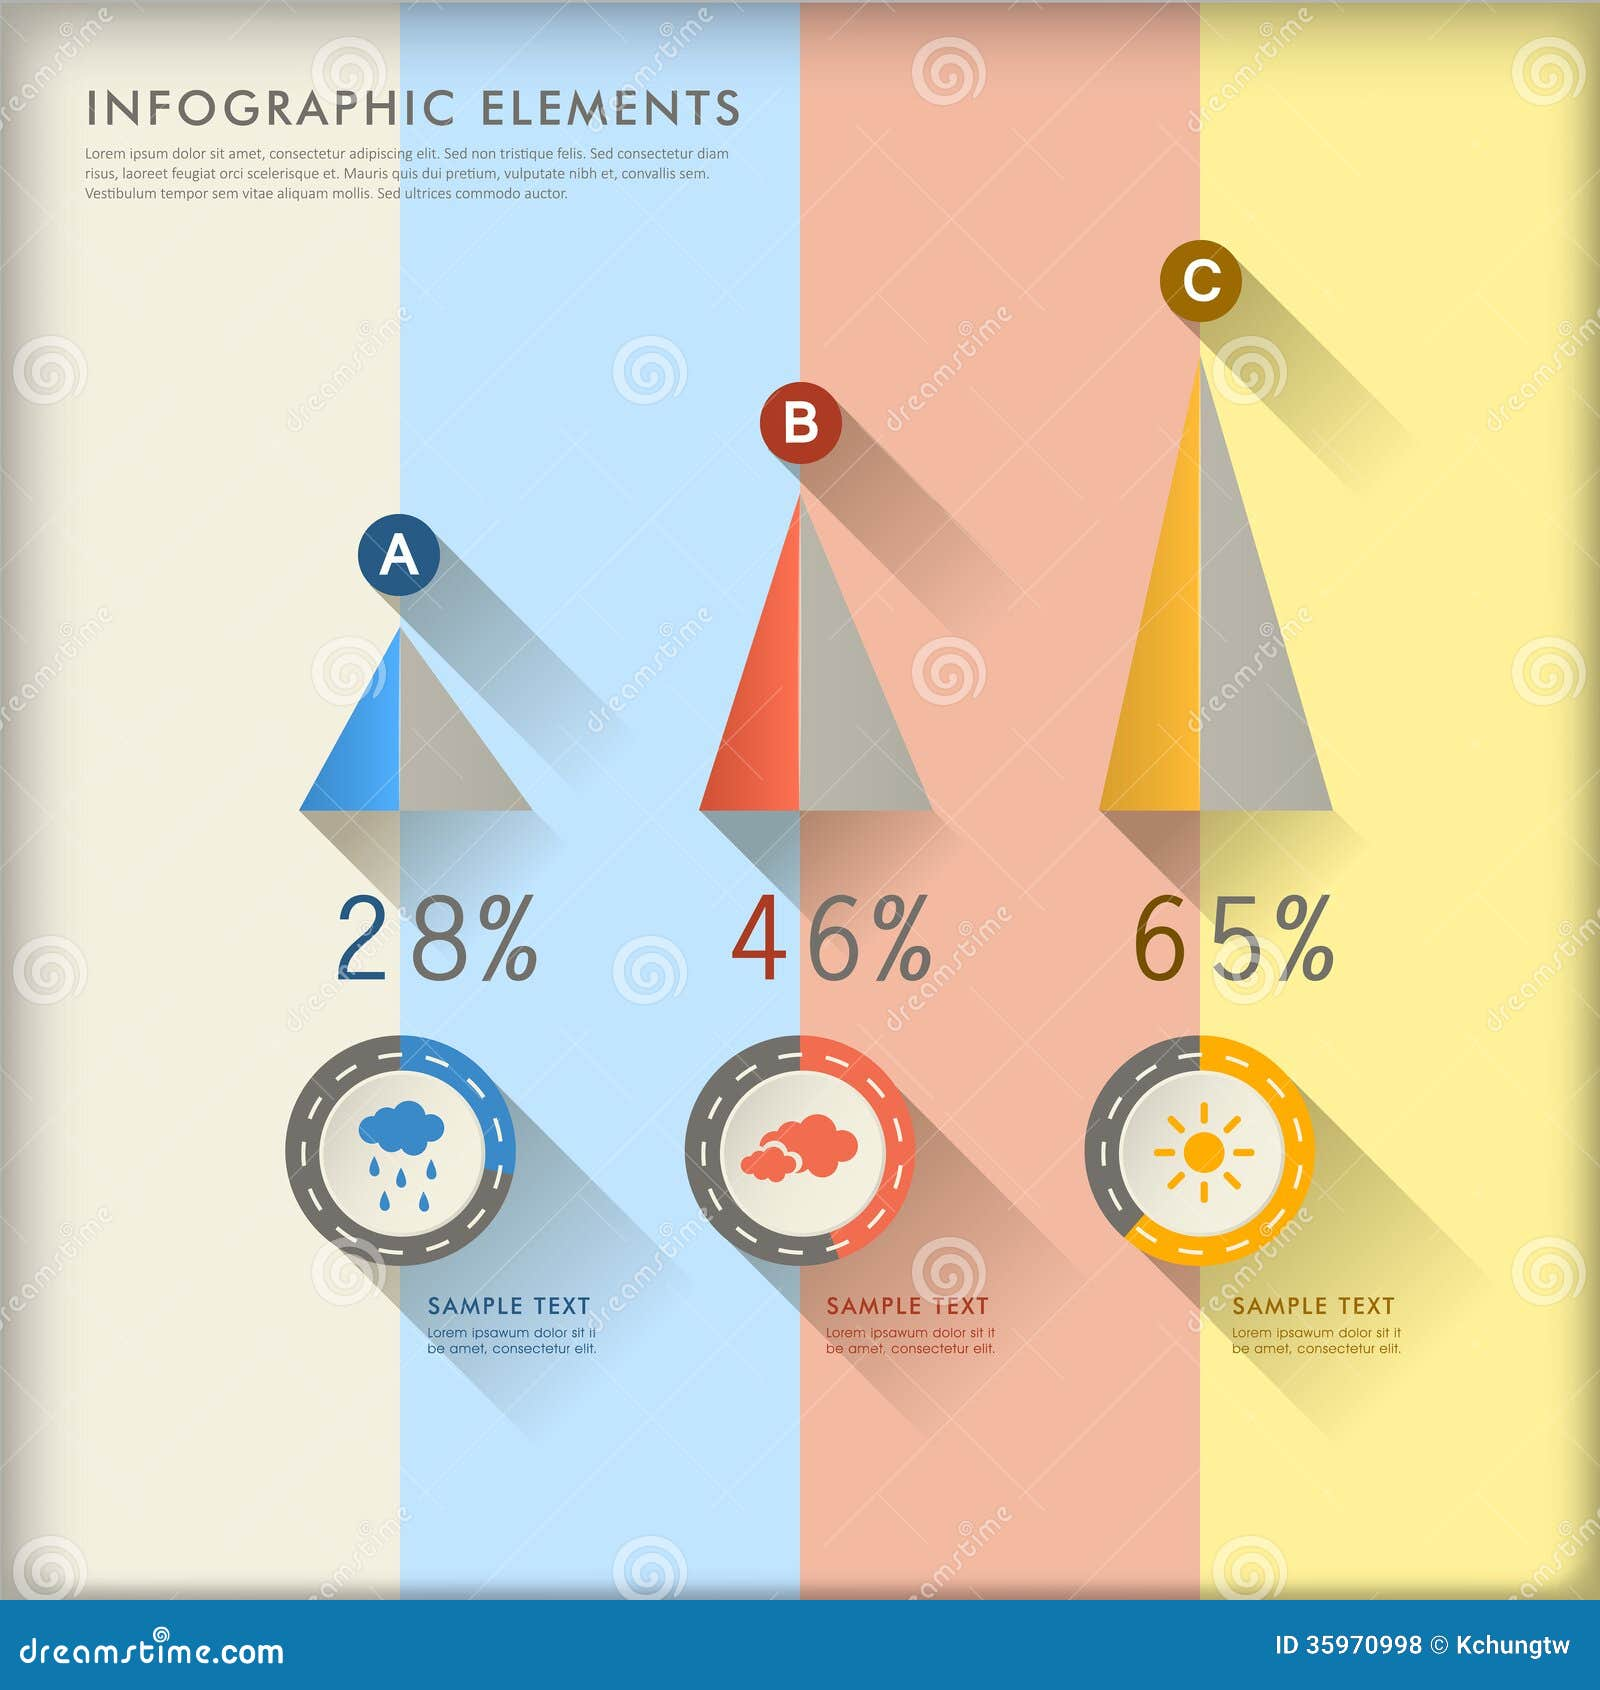Imagine this infographic shows the distribution of favorite activities among children in a summer camp. What might these activities be, and how does the design support this? In this context, the infographic could be showing the distribution of favorite activities among children at a summer camp. The rain cloud with 28% might represent interest in rainy-day indoor activities like arts and crafts or storytelling sessions. The red cloud with 46% could symbolize more adventurous and slightly risky activities, such as a ropes course or rock climbing. The sun with 65% might represent the most favored outdoor activities under the sun, like swimming, field games, or nature hikes. The design supports this by using playful and colorful icons that resonate with children, along with clear percentages to make it easy for them and their guardians to understand the prevalence of each activity at a glance. 